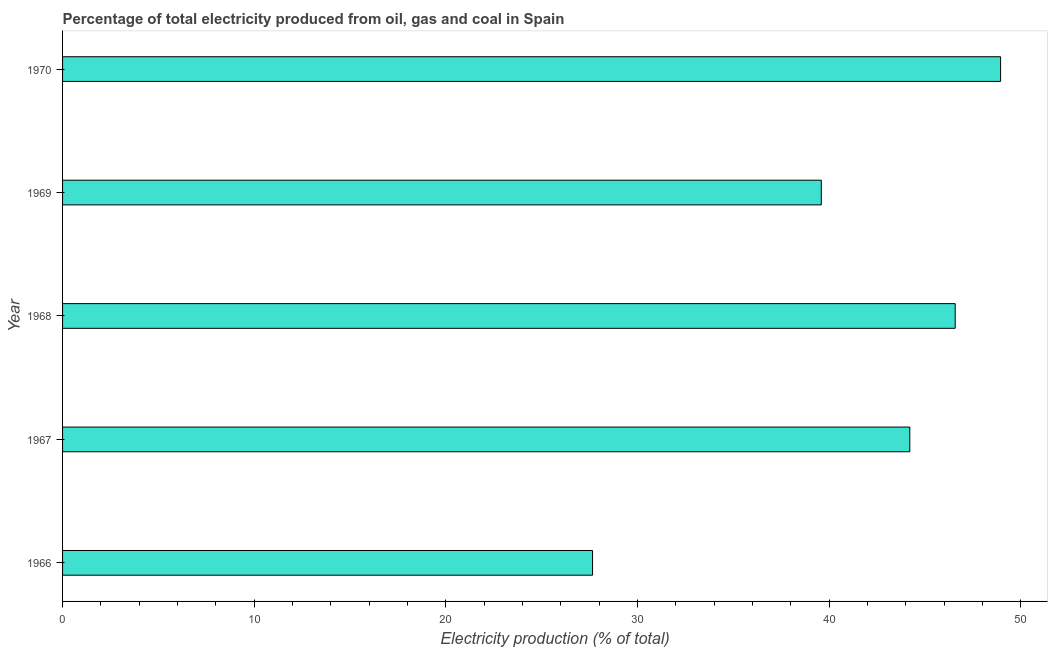Does the graph contain grids?
Offer a very short reply. No. What is the title of the graph?
Keep it short and to the point. Percentage of total electricity produced from oil, gas and coal in Spain. What is the label or title of the X-axis?
Offer a terse response. Electricity production (% of total). What is the electricity production in 1970?
Offer a very short reply. 48.95. Across all years, what is the maximum electricity production?
Your response must be concise. 48.95. Across all years, what is the minimum electricity production?
Your response must be concise. 27.66. In which year was the electricity production maximum?
Provide a short and direct response. 1970. In which year was the electricity production minimum?
Give a very brief answer. 1966. What is the sum of the electricity production?
Your response must be concise. 207. What is the difference between the electricity production in 1967 and 1970?
Your answer should be compact. -4.74. What is the average electricity production per year?
Your answer should be compact. 41.4. What is the median electricity production?
Keep it short and to the point. 44.21. In how many years, is the electricity production greater than 24 %?
Ensure brevity in your answer.  5. What is the ratio of the electricity production in 1966 to that in 1969?
Provide a succinct answer. 0.7. Is the electricity production in 1967 less than that in 1969?
Provide a short and direct response. No. Is the difference between the electricity production in 1967 and 1969 greater than the difference between any two years?
Offer a terse response. No. What is the difference between the highest and the second highest electricity production?
Give a very brief answer. 2.37. What is the difference between the highest and the lowest electricity production?
Keep it short and to the point. 21.29. In how many years, is the electricity production greater than the average electricity production taken over all years?
Make the answer very short. 3. How many bars are there?
Offer a very short reply. 5. Are all the bars in the graph horizontal?
Offer a terse response. Yes. What is the difference between two consecutive major ticks on the X-axis?
Provide a succinct answer. 10. Are the values on the major ticks of X-axis written in scientific E-notation?
Provide a succinct answer. No. What is the Electricity production (% of total) in 1966?
Make the answer very short. 27.66. What is the Electricity production (% of total) in 1967?
Give a very brief answer. 44.21. What is the Electricity production (% of total) of 1968?
Your answer should be compact. 46.58. What is the Electricity production (% of total) in 1969?
Your response must be concise. 39.6. What is the Electricity production (% of total) in 1970?
Your answer should be very brief. 48.95. What is the difference between the Electricity production (% of total) in 1966 and 1967?
Keep it short and to the point. -16.56. What is the difference between the Electricity production (% of total) in 1966 and 1968?
Offer a very short reply. -18.93. What is the difference between the Electricity production (% of total) in 1966 and 1969?
Give a very brief answer. -11.94. What is the difference between the Electricity production (% of total) in 1966 and 1970?
Offer a very short reply. -21.29. What is the difference between the Electricity production (% of total) in 1967 and 1968?
Your answer should be compact. -2.37. What is the difference between the Electricity production (% of total) in 1967 and 1969?
Give a very brief answer. 4.62. What is the difference between the Electricity production (% of total) in 1967 and 1970?
Ensure brevity in your answer.  -4.74. What is the difference between the Electricity production (% of total) in 1968 and 1969?
Ensure brevity in your answer.  6.99. What is the difference between the Electricity production (% of total) in 1968 and 1970?
Make the answer very short. -2.37. What is the difference between the Electricity production (% of total) in 1969 and 1970?
Keep it short and to the point. -9.36. What is the ratio of the Electricity production (% of total) in 1966 to that in 1967?
Keep it short and to the point. 0.63. What is the ratio of the Electricity production (% of total) in 1966 to that in 1968?
Ensure brevity in your answer.  0.59. What is the ratio of the Electricity production (% of total) in 1966 to that in 1969?
Ensure brevity in your answer.  0.7. What is the ratio of the Electricity production (% of total) in 1966 to that in 1970?
Ensure brevity in your answer.  0.56. What is the ratio of the Electricity production (% of total) in 1967 to that in 1968?
Your response must be concise. 0.95. What is the ratio of the Electricity production (% of total) in 1967 to that in 1969?
Provide a short and direct response. 1.12. What is the ratio of the Electricity production (% of total) in 1967 to that in 1970?
Offer a terse response. 0.9. What is the ratio of the Electricity production (% of total) in 1968 to that in 1969?
Your answer should be compact. 1.18. What is the ratio of the Electricity production (% of total) in 1969 to that in 1970?
Give a very brief answer. 0.81. 